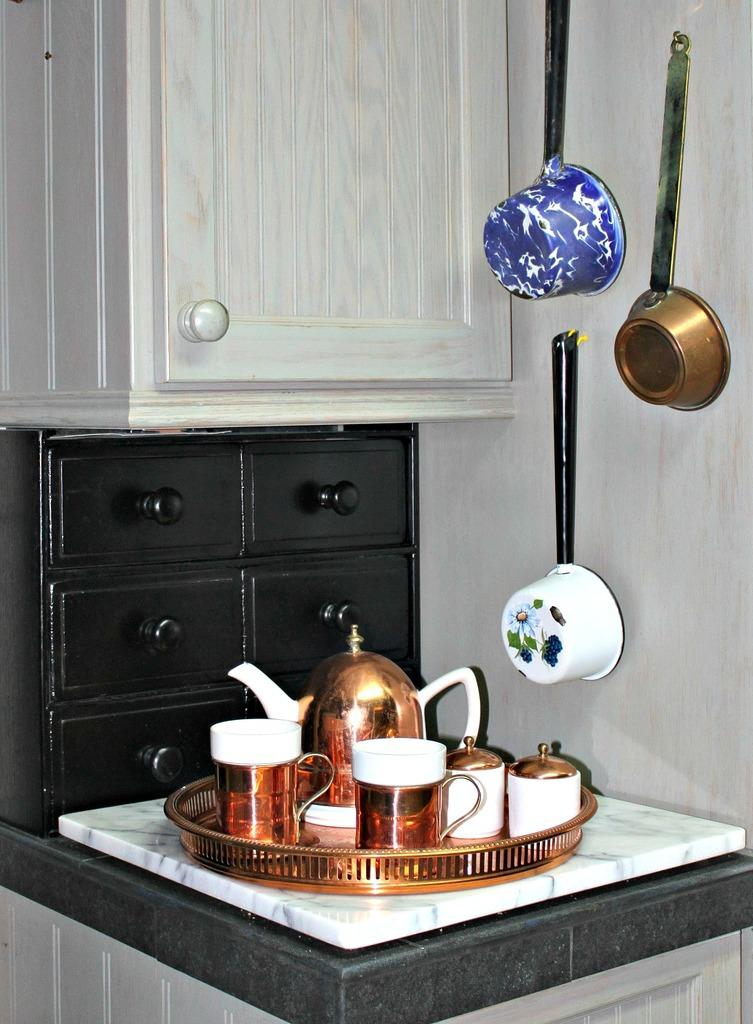What objects are on the platform in the image? There are cups and a mug on a platform in the image. What can be seen in the background of the image? There are cupboards in the background of the image. Where are the utensils located in the image? The utensils are on the wall in the image. How many hens are sitting on the platform in the image? There are no hens present in the image; it features cups, a mug, cupboards, and utensils. What type of leg is visible on the platform in the image? There is no leg visible on the platform in the image; it features cups, a mug, cupboards, and utensils. 